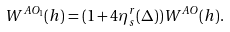<formula> <loc_0><loc_0><loc_500><loc_500>W ^ { A O _ { 1 } } ( h ) = ( 1 + 4 \eta _ { s } ^ { r } ( \Delta ) ) W ^ { A O } ( h ) .</formula> 